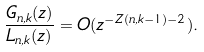<formula> <loc_0><loc_0><loc_500><loc_500>\frac { G _ { n , k } ( z ) } { L _ { n , k } ( z ) } = O ( z ^ { - Z ( n , k - 1 ) - 2 } ) .</formula> 